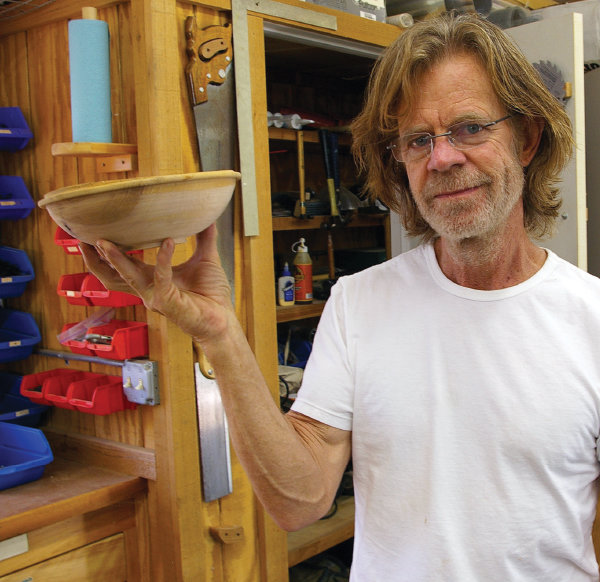What types of tools can you identify in the background, and what might they tell us about the woodworking projects undertaken here? In the background, you can see a variety of clamps, a bandsaw, and several chisels, indicating the capability to undertake complex woodworking projects. The presence of fine-detail tools like chisels suggests that precision work, such as carving and shaping small objects or intricate designs, is performed here. Additionally, the diverse range of clamps points to projects that require assembly or gluing, which could include furniture making or decorative art pieces. 